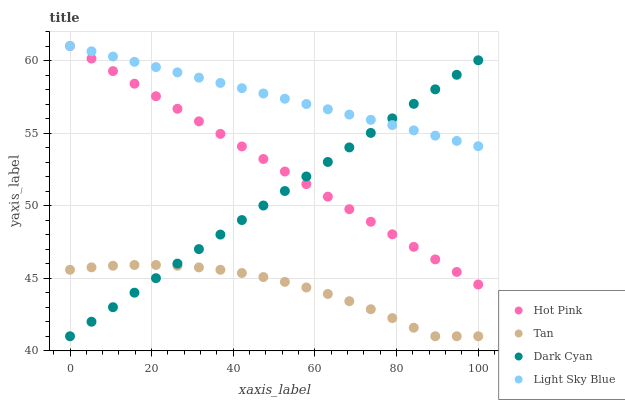Does Tan have the minimum area under the curve?
Answer yes or no. Yes. Does Light Sky Blue have the maximum area under the curve?
Answer yes or no. Yes. Does Hot Pink have the minimum area under the curve?
Answer yes or no. No. Does Hot Pink have the maximum area under the curve?
Answer yes or no. No. Is Hot Pink the smoothest?
Answer yes or no. Yes. Is Tan the roughest?
Answer yes or no. Yes. Is Tan the smoothest?
Answer yes or no. No. Is Hot Pink the roughest?
Answer yes or no. No. Does Dark Cyan have the lowest value?
Answer yes or no. Yes. Does Hot Pink have the lowest value?
Answer yes or no. No. Does Light Sky Blue have the highest value?
Answer yes or no. Yes. Does Tan have the highest value?
Answer yes or no. No. Is Tan less than Light Sky Blue?
Answer yes or no. Yes. Is Hot Pink greater than Tan?
Answer yes or no. Yes. Does Dark Cyan intersect Light Sky Blue?
Answer yes or no. Yes. Is Dark Cyan less than Light Sky Blue?
Answer yes or no. No. Is Dark Cyan greater than Light Sky Blue?
Answer yes or no. No. Does Tan intersect Light Sky Blue?
Answer yes or no. No. 